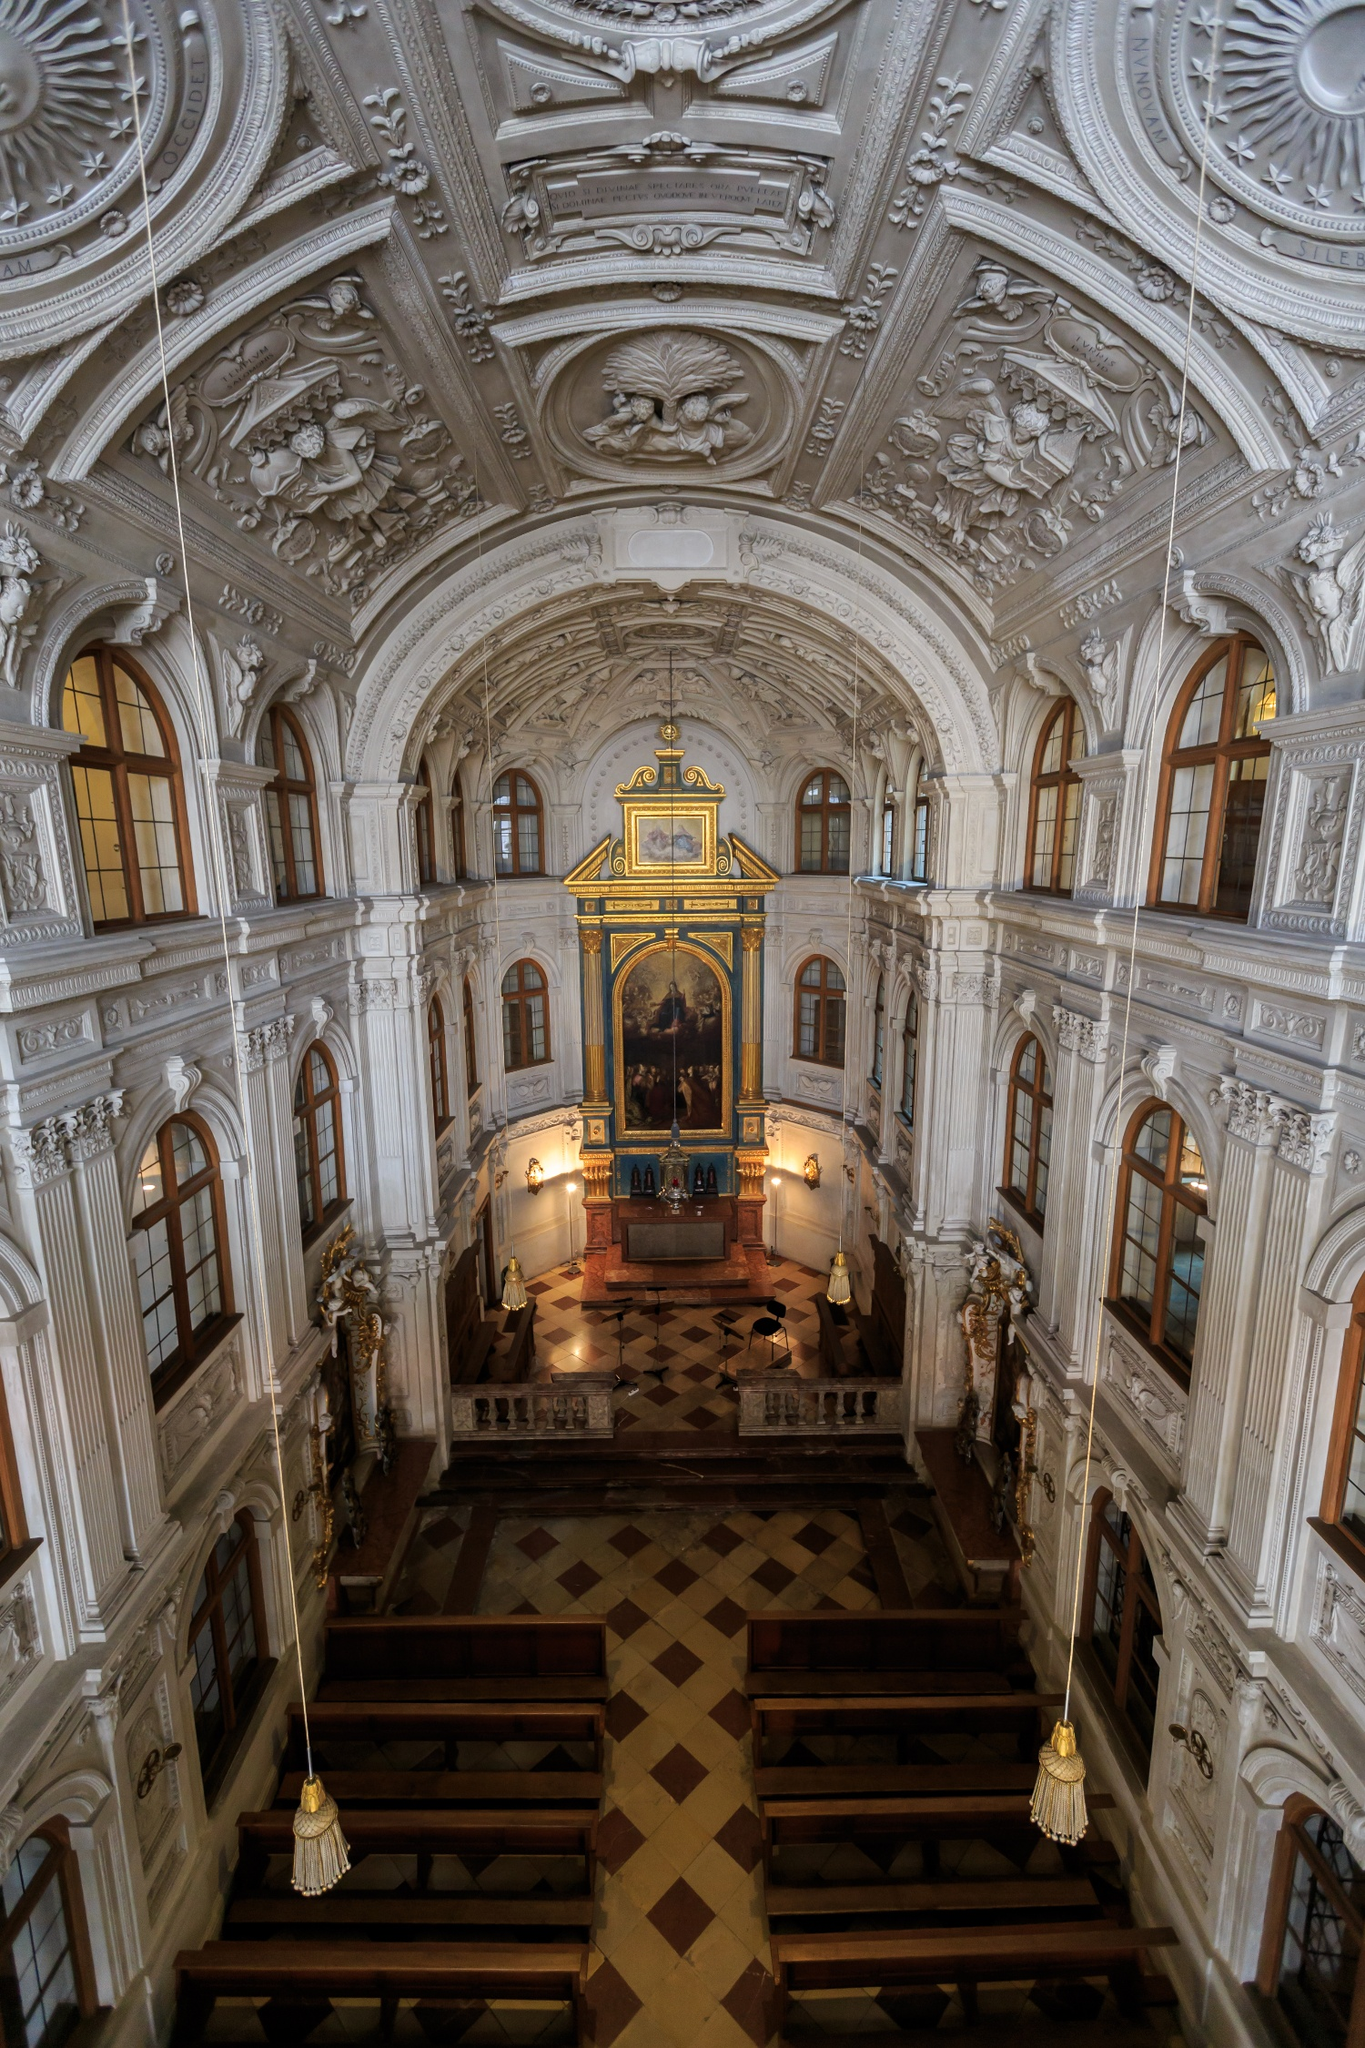Imagine if this church could talk. What stories do you think it would tell about its past? If the Hofkirche could talk, it would tell tales of grand ceremonies, royal weddings, and solemn funerals. It would recount the sorrow of wartime bombings and the joy of its meticulous restoration. The church would share stories of the people who sought solace within its walls, the artists and craftsmen who dedicated their skills to its creation, and the countless prayers whispered beneath its arched ceilings. This venerable structure has been a silent witness to the ebb and flow of Dresden's history, bearing timeless testament to both human frailty and resilience. 